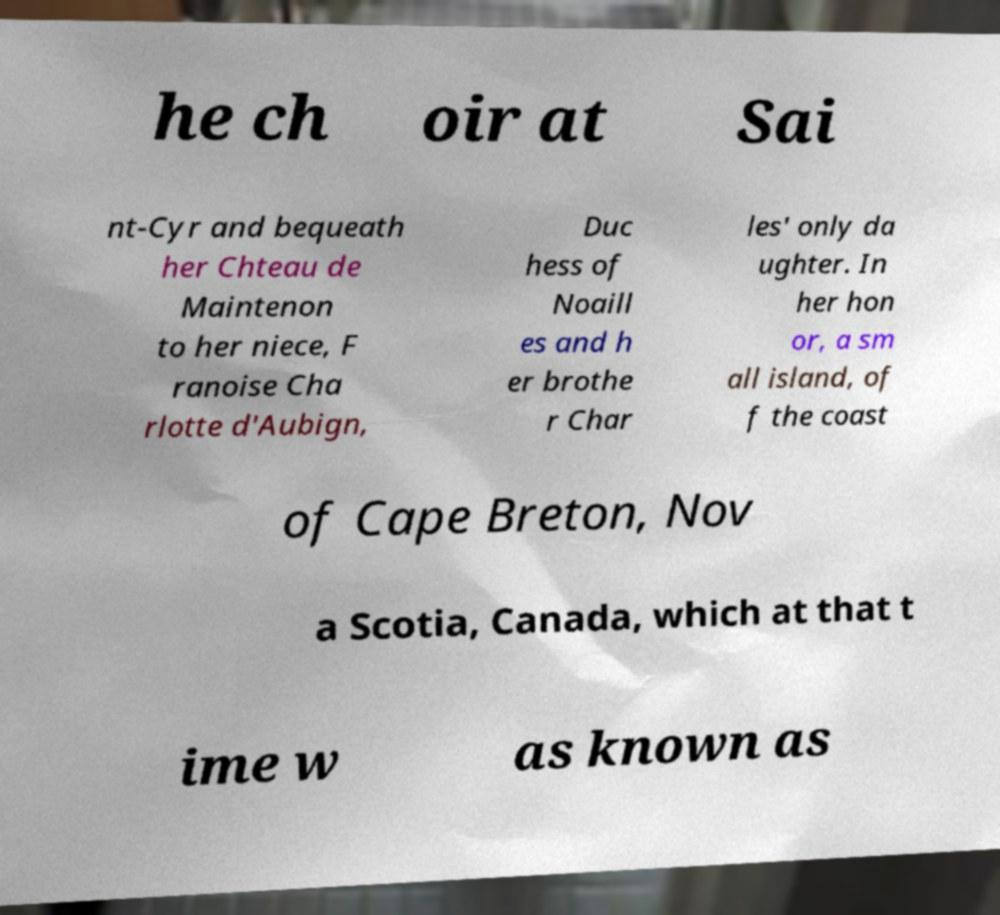Please identify and transcribe the text found in this image. he ch oir at Sai nt-Cyr and bequeath her Chteau de Maintenon to her niece, F ranoise Cha rlotte d'Aubign, Duc hess of Noaill es and h er brothe r Char les' only da ughter. In her hon or, a sm all island, of f the coast of Cape Breton, Nov a Scotia, Canada, which at that t ime w as known as 